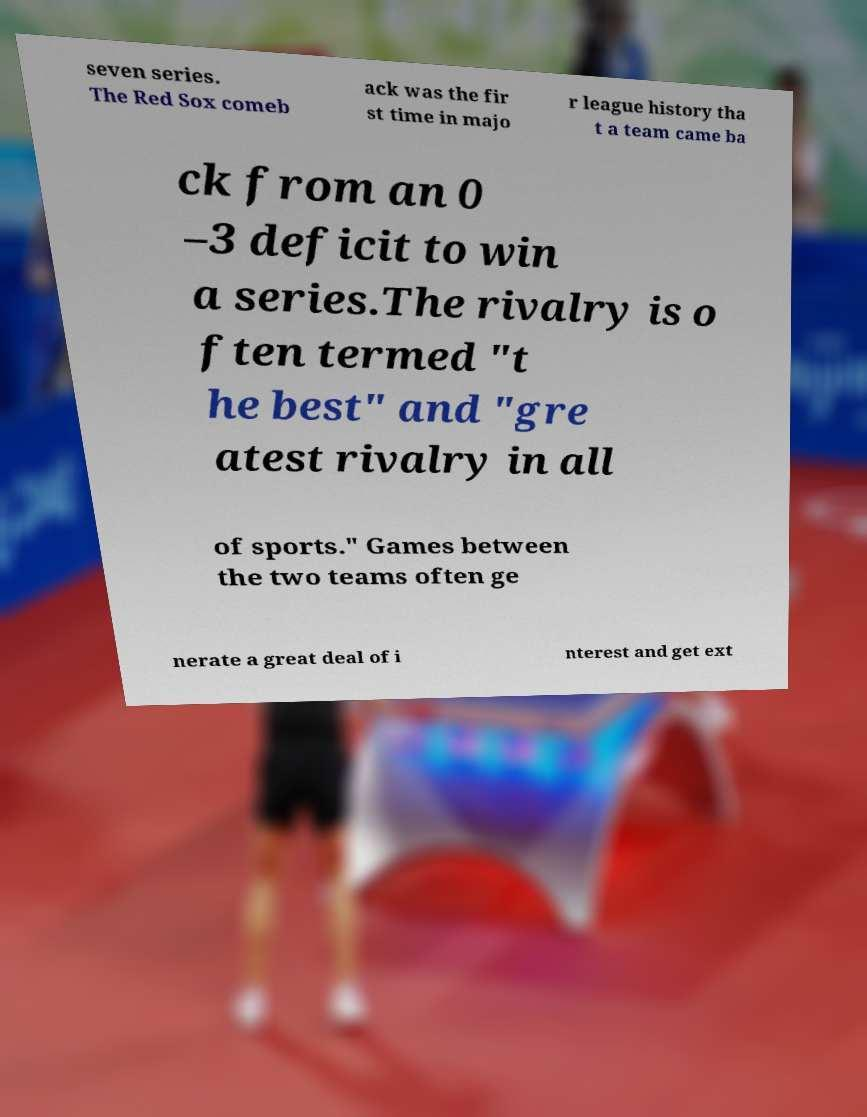What messages or text are displayed in this image? I need them in a readable, typed format. seven series. The Red Sox comeb ack was the fir st time in majo r league history tha t a team came ba ck from an 0 –3 deficit to win a series.The rivalry is o ften termed "t he best" and "gre atest rivalry in all of sports." Games between the two teams often ge nerate a great deal of i nterest and get ext 